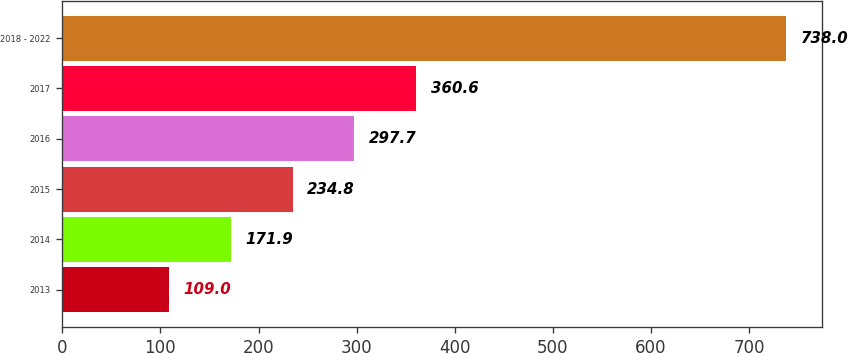Convert chart to OTSL. <chart><loc_0><loc_0><loc_500><loc_500><bar_chart><fcel>2013<fcel>2014<fcel>2015<fcel>2016<fcel>2017<fcel>2018 - 2022<nl><fcel>109<fcel>171.9<fcel>234.8<fcel>297.7<fcel>360.6<fcel>738<nl></chart> 